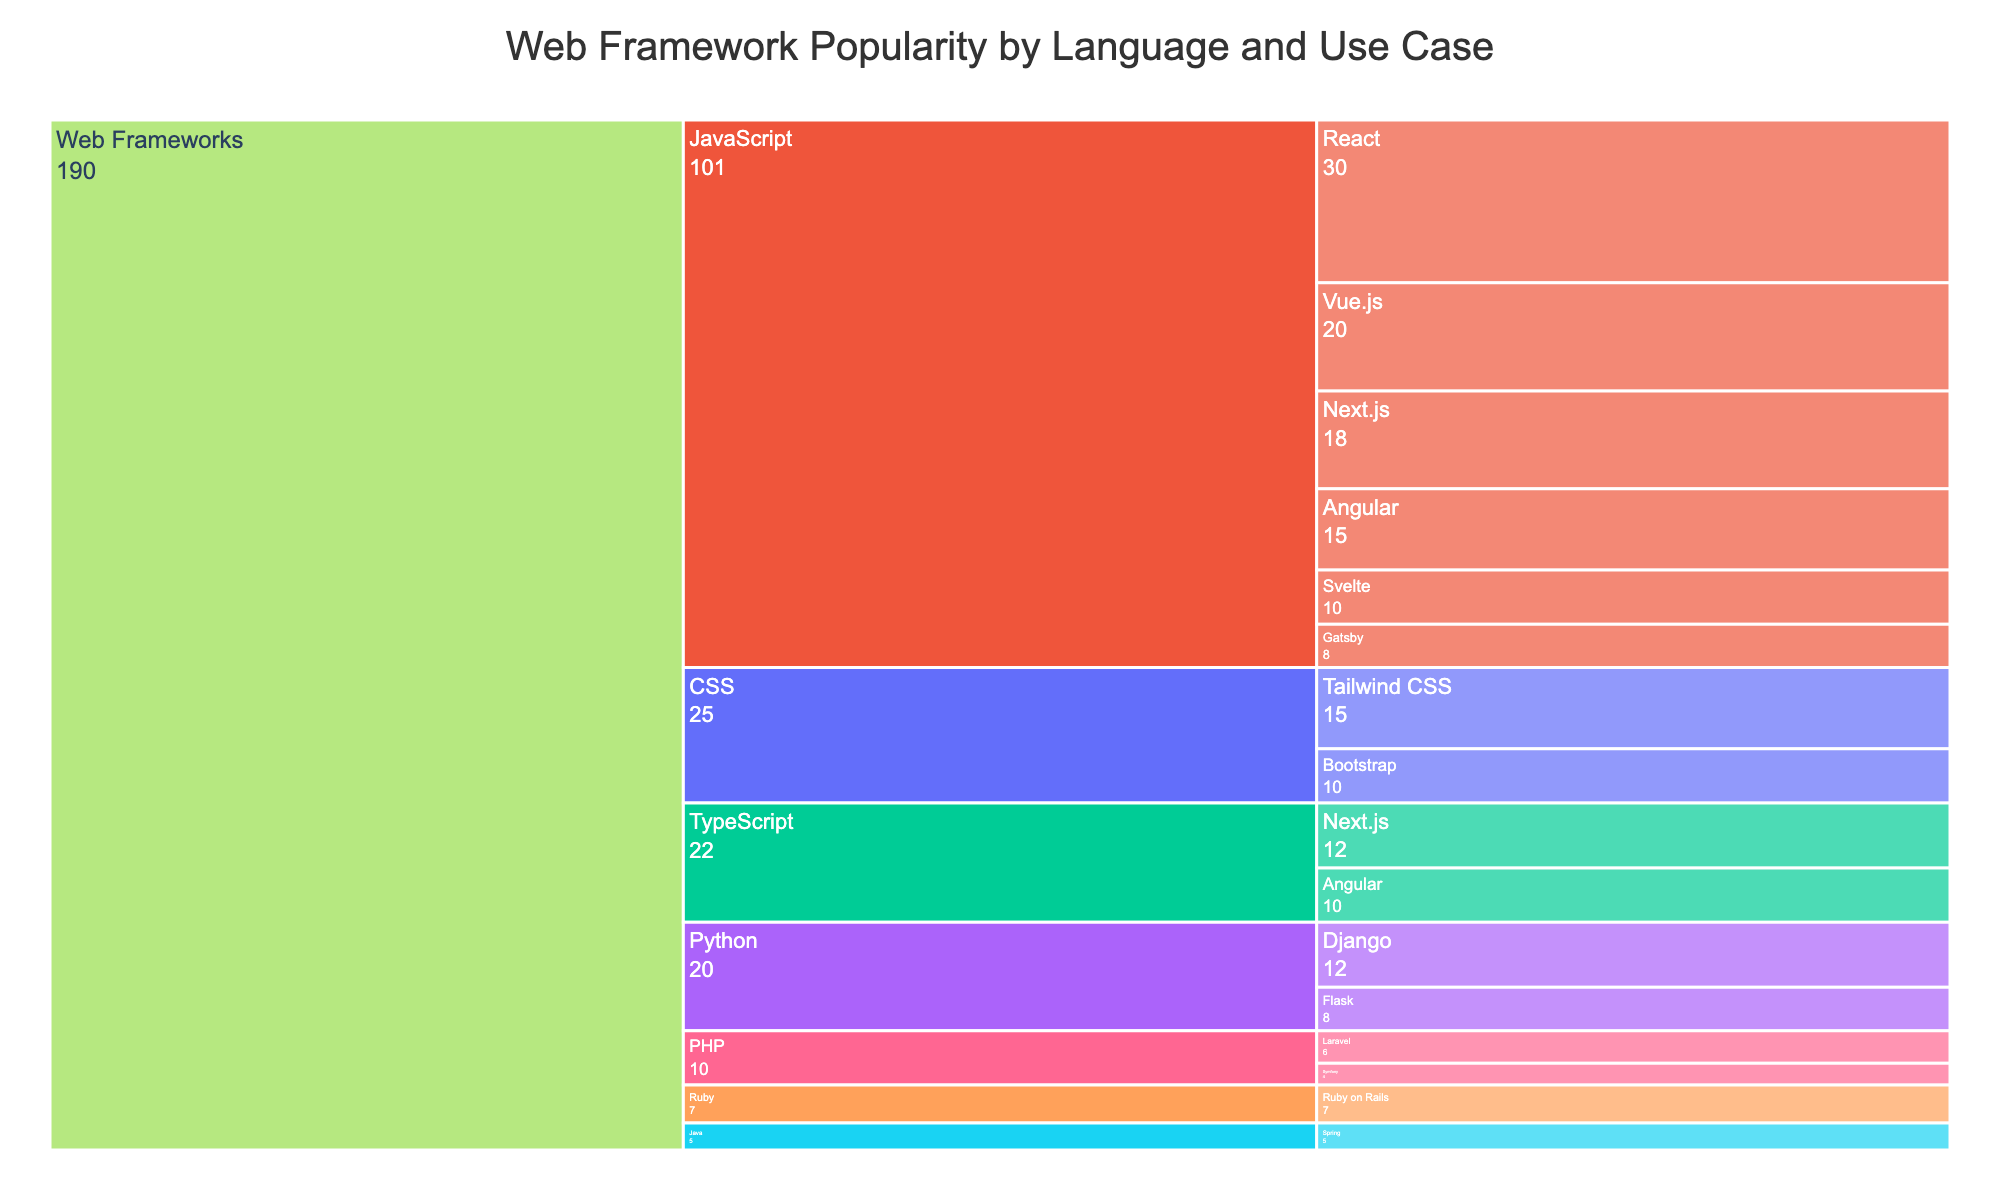What's the most popular JavaScript framework? The Icicle chart shows the popularity of frameworks broken down by language. By following the JavaScript category, React has the highest value of 30 within this category.
Answer: React Which CSS framework is more popular, Tailwind CSS or Bootstrap? Both Tailwind CSS and Bootstrap are in the CSS category of the Icicle chart. Tailwind CSS has a value of 15, whereas Bootstrap has a value of 10.
Answer: Tailwind CSS What is the combined popularity score of Django and Flask? Look within the Python category in the Icicle chart and sum the values of Django and Flask. Django has a value of 12 and Flask has a value of 8. The combined score is 12 + 8 = 20.
Answer: 20 How many frameworks are listed under JavaScript? The JavaScript category in the Icicle chart consists of React, Vue.js, Angular, Svelte, Next.js, and Gatsby. Count these subcategories.
Answer: 6 Which language has the least popular framework, and what is the framework? Look for the framework with the smallest value. PHP has a framework called Symfony with the value of 4.
Answer: PHP, Symfony Is Angular more popular in its JavaScript or TypeScript version? Angular is present in both the JavaScript and TypeScript categories. In the JavaScript category, Angular has a value of 15. In the TypeScript category, Angular has a value of 10.
Answer: JavaScript What is the total popularity score for all frameworks under the Java category? Sum the values of all frameworks under Java in the Icicle chart. The Java category only has Spring with a value of 5.
Answer: 5 Which language category has the highest total popularity score? Sum the values of all frameworks within each language category and compare them. JavaScript has React (30), Vue.js (20), Angular (15), Svelte (10), Next.js (18), and Gatsby (8), totaling 101. Python has Django (12) and Flask (8), totaling 20. Ruby has Ruby on Rails (7). PHP has Laravel (6) and Symfony (4), totaling 10. Java has Spring (5). TypeScript has Angular (10) and Next.js (12), totaling 22. CSS has Tailwind CSS (15) and Bootstrap (10), totaling 25. JavaScript has the highest score.
Answer: JavaScript What is the average popularity score among the JavaScript frameworks? To find the average, sum the values of all JavaScript frameworks and divide by the number of them. Total is 101, and there are 6 frameworks: 101 / 6 ≈ 16.83.
Answer: 16.83 What's the least popular framework in the CSS category? Within the CSS category in the Icicle chart, compare the values of Tailwind CSS and Bootstrap. Tailwind CSS has a value of 15 and Bootstrap has a value of 10.
Answer: Bootstrap 